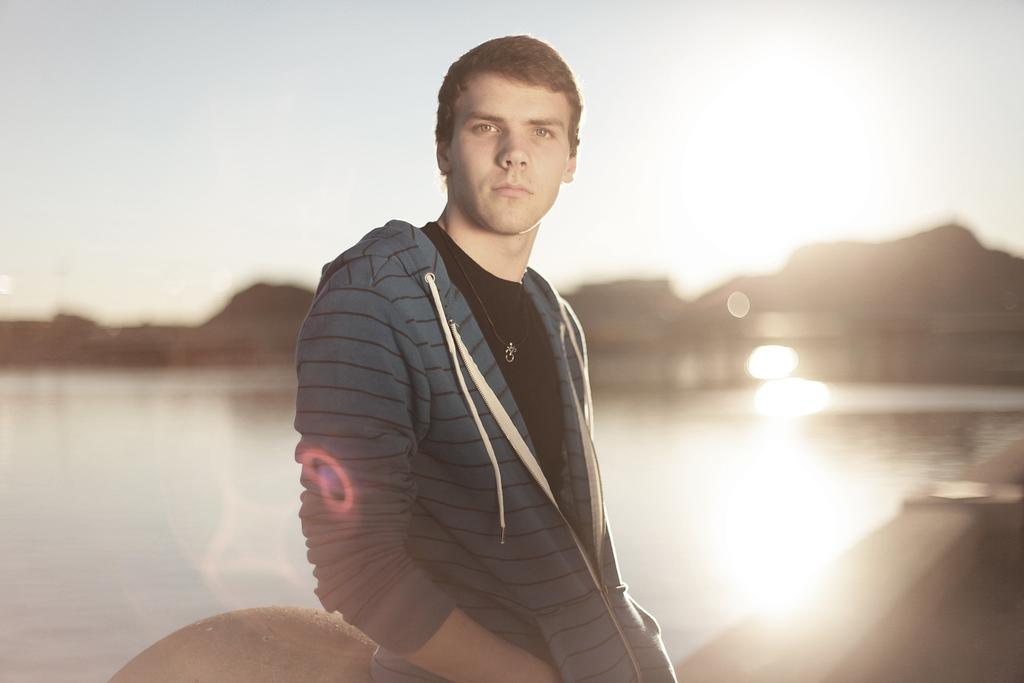Who or what is in the image? There is a person in the image. What can be seen in the background of the image? There is sky, mountains, and water visible in the background of the image. What type of cloth is being used to protect the person from the rainstorm in the image? There is no rainstorm present in the image, and therefore no cloth for protection. 